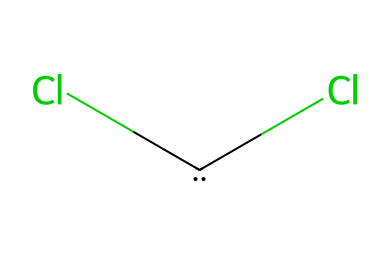What type of functional groups are present in this molecule? The molecule contains two chlorine atoms attached to a carbon atom, indicating it has two halogen (chlorine) substituents.
Answer: halogen How many carbon atoms are in the structure? The SMILES representation shows one carbon atom indicated by the '[C]' symbol.
Answer: one What is the hybridization of the central carbon in this structure? The central carbon has two single bonds to chlorine and one empty p-orbital because of its divalent nature typical in carbenes. This implies it is sp² hybridized.
Answer: sp² Which type of reaction can dihalocarbenes participate in? Dihalocarbenes can participate in cyclopropanation reactions, which involve the addition of a carbene to alkenes to form cyclopropane.
Answer: cyclopropanation What is the basic skeleton of this molecule? The core structure consists of a carbon atom at the center with two chlorine atoms attached, representing a dichloro group bonded to a carbene.
Answer: dichloro What is the expected geometry around the central carbon atom in this dihalocarbene? The central carbon atom is sp² hybridized, which leads to a trigonal planar geometry around it due to the arrangement of atoms and lone pairs.
Answer: trigonal planar 